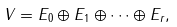<formula> <loc_0><loc_0><loc_500><loc_500>V = E _ { 0 } \oplus E _ { 1 } \oplus \dots \oplus E _ { r } ,</formula> 